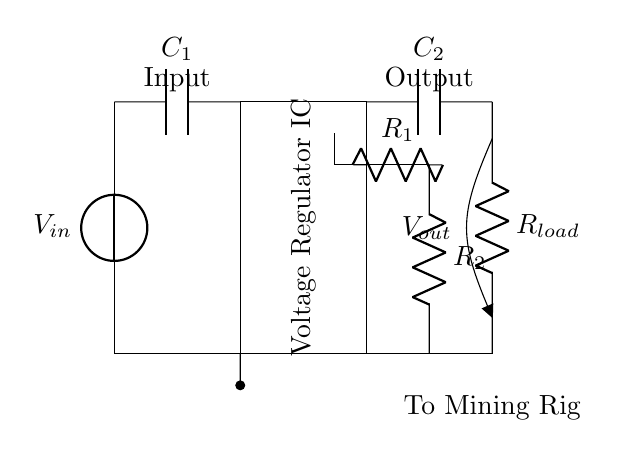What is the purpose of the voltage regulator IC? The voltage regulator IC stabilizes the output voltage, ensuring that the power supply remains consistent for the connected load, despite variations in the input voltage or load changes.
Answer: Stabilization What type of components are C1 and C2? C1 and C2 are capacitors used to filter and stabilize the input and output voltages, which helps smooth out voltage fluctuations, providing a more stable current flow to the mining rig.
Answer: Capacitors What does R_load represent in the circuit? R_load represents the load resistor, which simulates the power consumption of the cryptocurrency mining rig, effectively determining how much current is drawn from the voltage regulator.
Answer: Load resistor How many feedback resistors are used in this circuit? There are two feedback resistors, R1 and R2, that provide a feedback mechanism to the voltage regulator, allowing it to adjust its output based on the load conditions and maintain the desired voltage.
Answer: Two What is the output voltage denoted as in the circuit? The output voltage is denoted as V_out, located at the point where the load connects to the circuit, indicating the regulated voltage supplied to the mining rig.
Answer: V_out If the input voltage increases, what will likely happen to V_out? If the input voltage increases, the voltage regulator IC will adjust to maintain V_out at a stable level; it is designed to output a constant voltage regardless of input fluctuations within its specifications.
Answer: Remains stable What is the function of the capacitors in this circuit? The function of the capacitors C1 and C2 is to filter and smooth the input and output voltage signals, which reduces voltage ripple and ensures a steady supply of power to the load.
Answer: Filtering 